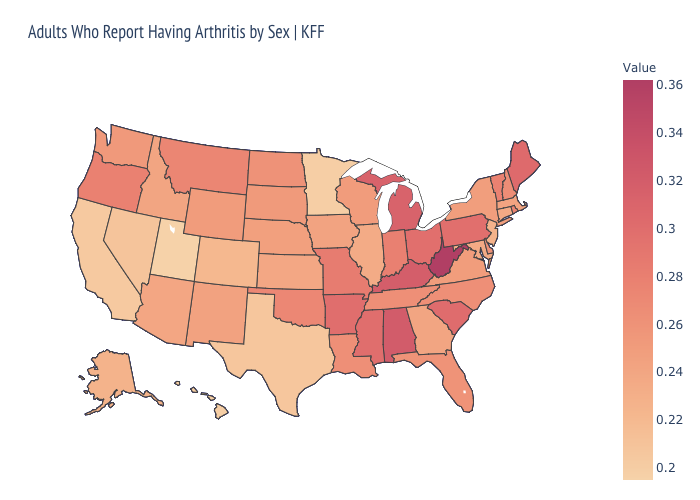Is the legend a continuous bar?
Keep it brief. Yes. Among the states that border New York , which have the highest value?
Short answer required. Pennsylvania. Does New Mexico have the highest value in the West?
Keep it brief. No. Does Illinois have the highest value in the USA?
Answer briefly. No. Does Utah have the lowest value in the USA?
Short answer required. Yes. Among the states that border Michigan , which have the lowest value?
Keep it brief. Wisconsin. Among the states that border Georgia , does South Carolina have the lowest value?
Give a very brief answer. No. 